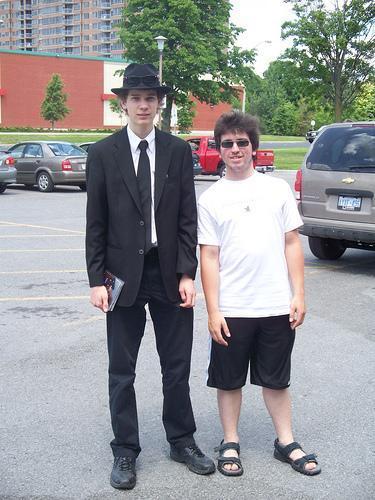How many cars are there?
Give a very brief answer. 5. How many cars are visible?
Give a very brief answer. 2. How many people are there?
Give a very brief answer. 2. 